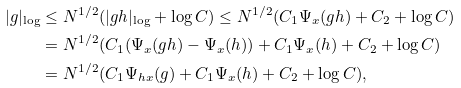<formula> <loc_0><loc_0><loc_500><loc_500>| g | _ { \log } & \leq N ^ { 1 / 2 } ( | g h | _ { \log } + \log C ) \leq N ^ { 1 / 2 } ( C _ { 1 } \Psi _ { x } ( g h ) + C _ { 2 } + \log C ) \\ & = N ^ { 1 / 2 } ( C _ { 1 } ( \Psi _ { x } ( g h ) - \Psi _ { x } ( h ) ) + C _ { 1 } \Psi _ { x } ( h ) + C _ { 2 } + \log C ) \\ & = N ^ { 1 / 2 } ( C _ { 1 } \Psi _ { h x } ( g ) + C _ { 1 } \Psi _ { x } ( h ) + C _ { 2 } + \log C ) ,</formula> 